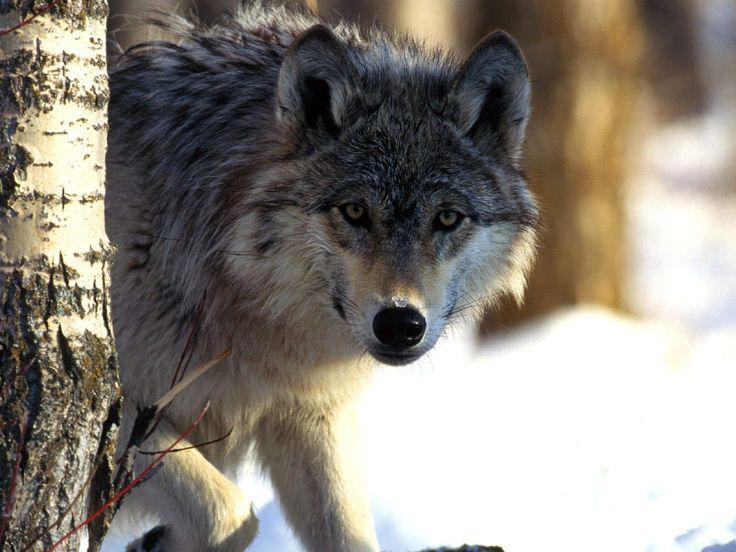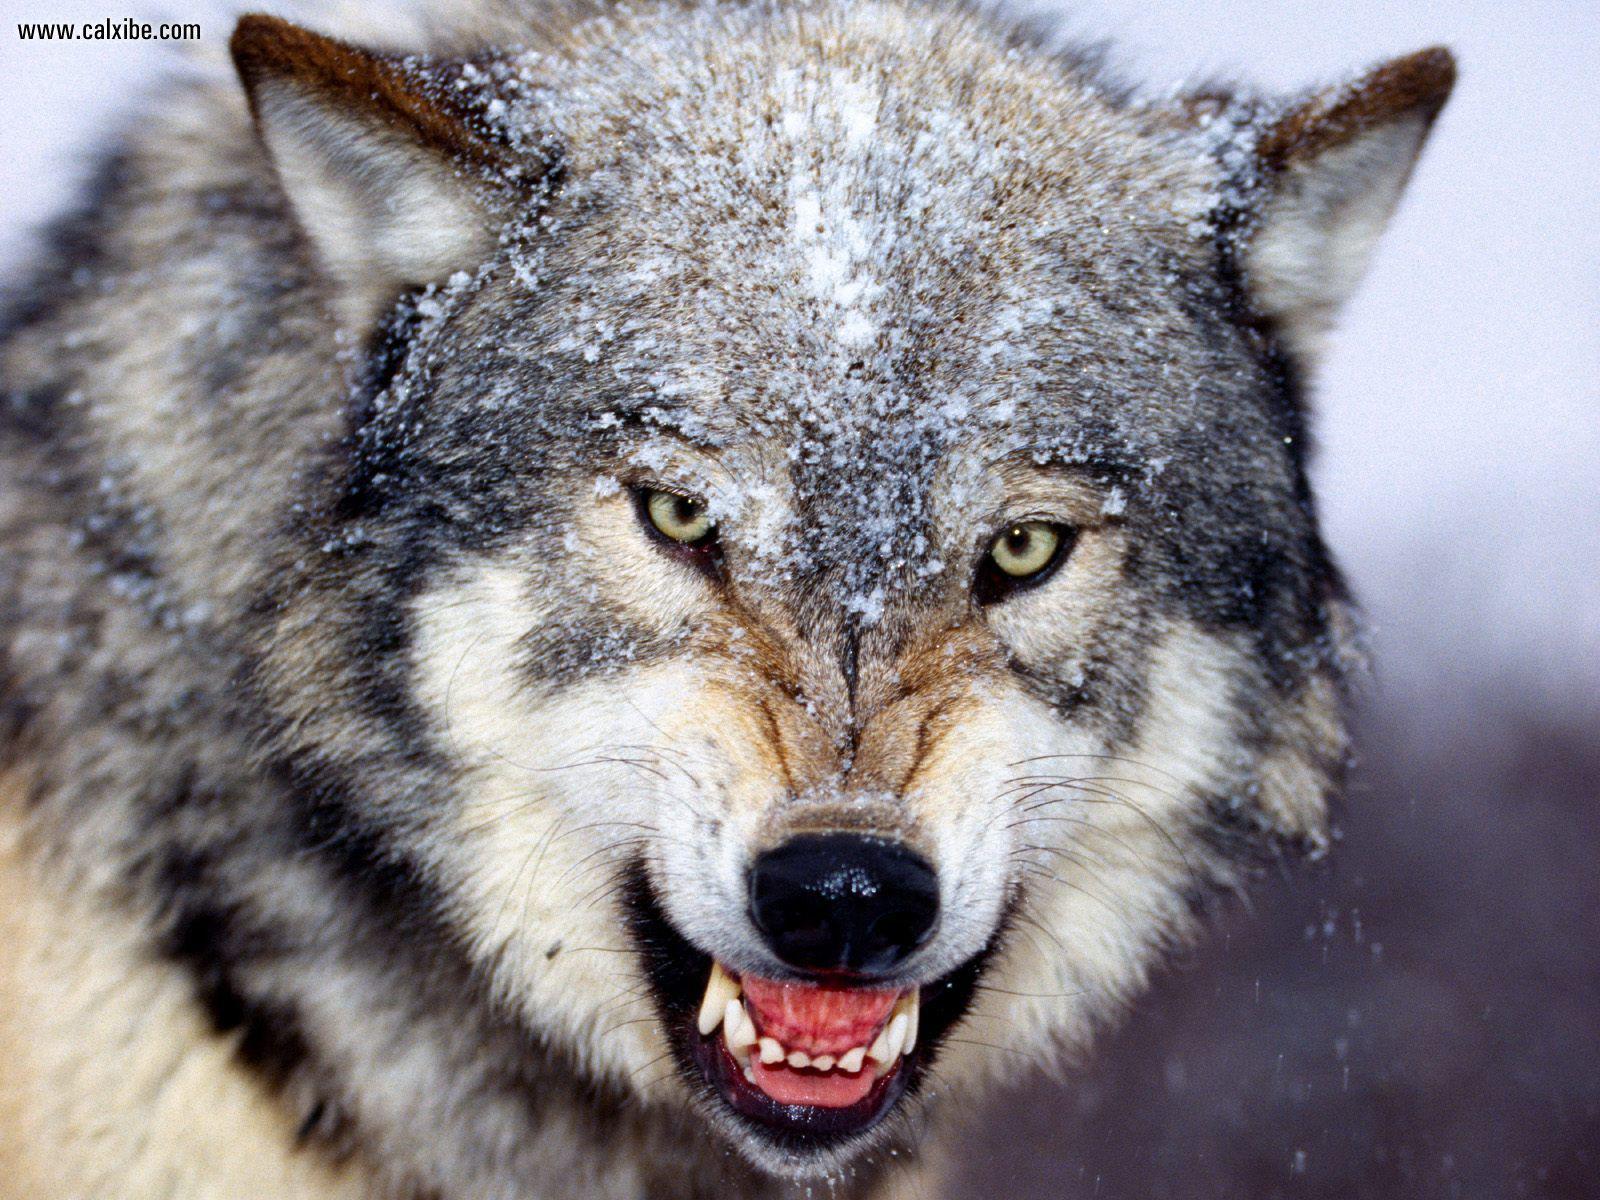The first image is the image on the left, the second image is the image on the right. Considering the images on both sides, is "At least one wolf is standing in front of trees with its head raised in a howling pose." valid? Answer yes or no. No. The first image is the image on the left, the second image is the image on the right. Examine the images to the left and right. Is the description "There is no more than one wolf in the right image." accurate? Answer yes or no. Yes. 